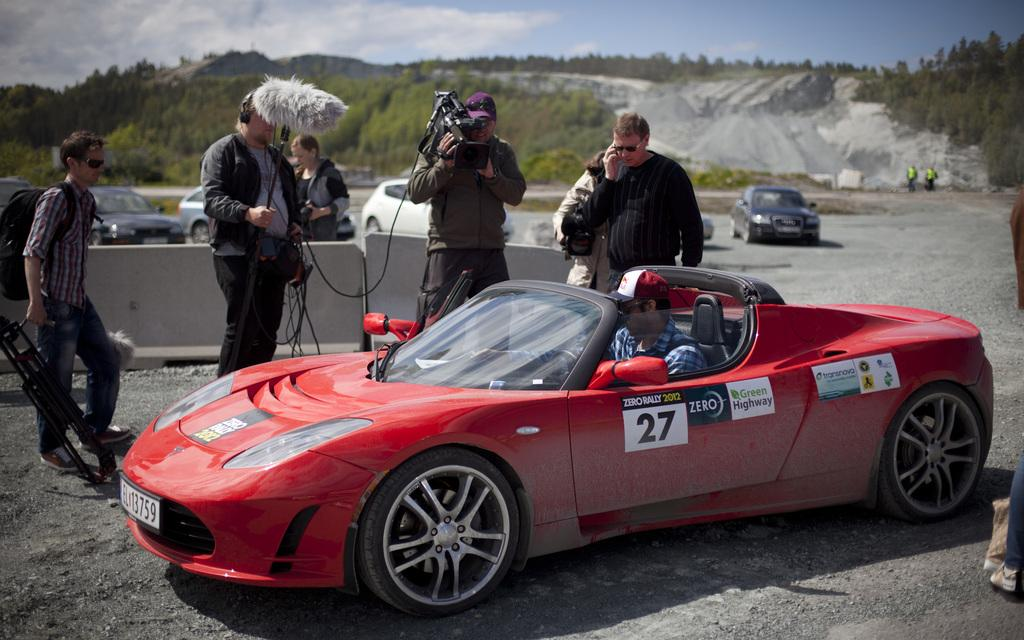What can be seen in the background of the image? There is a sky in the image. What type of vegetation is present in the image? There are trees in the image. What type of vehicles can be seen in the image? There are cars in the image. Who or what is present in the image? There are people in the image. What type of plough is being used by the people in the image? There is no plough present in the image; it features a sky, trees, cars, and people. What season is depicted in the image? The provided facts do not specify the season, so it cannot be determined from the image. 